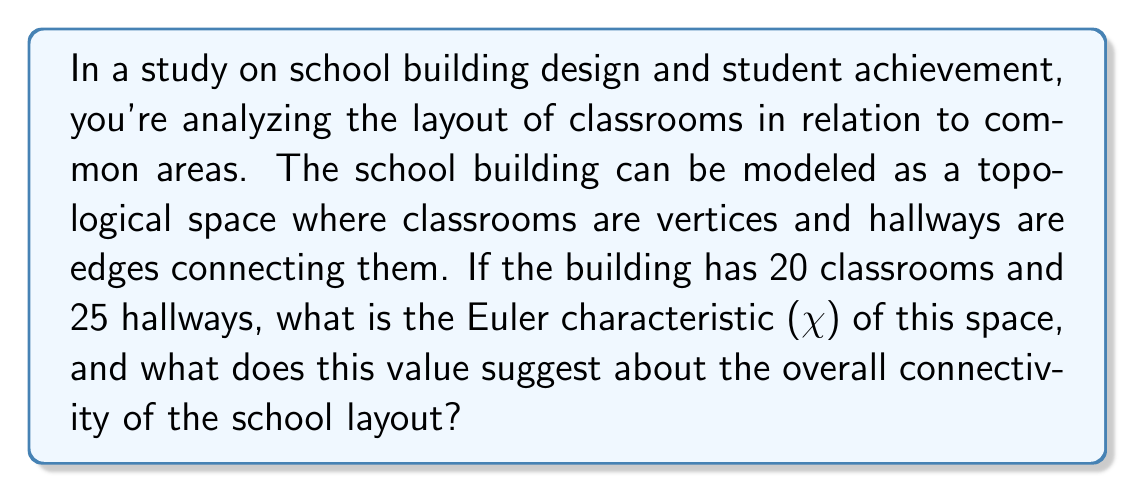What is the answer to this math problem? To solve this problem, we need to understand the concept of Euler characteristic in topology and how it relates to the given scenario.

1) The Euler characteristic ($\chi$) is a topological invariant that describes the shape or structure of a topological space regardless of how it is bent or stretched. For a graph (which is how we're modeling the school layout), it is calculated as:

   $$ \chi = V - E + F $$

   Where:
   $V$ = number of vertices (classrooms in this case)
   $E$ = number of edges (hallways)
   $F$ = number of faces (which is 1 for a planar graph, 0 for our 3D building model)

2) Given information:
   $V = 20$ (classrooms)
   $E = 25$ (hallways)
   $F = 0$ (no enclosed faces in a 3D building model)

3) Substituting these values into the formula:

   $$ \chi = 20 - 25 + 0 = -5 $$

4) Interpretation of the result:
   - A negative Euler characteristic suggests that the space has a high degree of connectivity or complexity.
   - In the context of a school building, this indicates a layout with multiple paths between classrooms and potentially circular or looping hallways.
   - Such a design could promote interaction between students from different classrooms and provide multiple routes to common areas, potentially influencing student movement patterns and social dynamics.

5) For a school principal interested in student outcomes, this topological analysis suggests:
   - The building design encourages student interaction and movement.
   - There may be benefits in terms of collaborative learning opportunities.
   - However, it could also present challenges in terms of student supervision and traffic flow management during class changes.

Understanding this topological property of the school layout can inform decisions about classroom assignments, scheduling, and even future building modifications to optimize the balance between connectivity and manageability.
Answer: The Euler characteristic ($\chi$) of the school building space is $-5$. This negative value suggests a highly connected and complex layout, which could promote student interaction but may also present challenges in traffic flow management. 